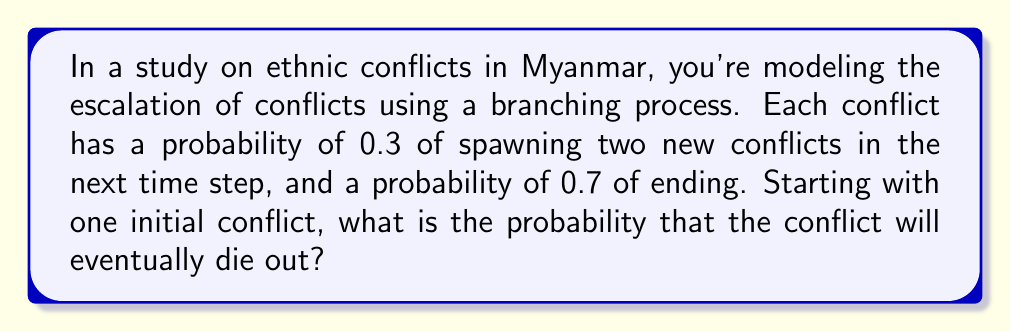Show me your answer to this math problem. To solve this problem, we'll use the theory of branching processes:

1) Let $p_0$ be the probability of a conflict ending (0.7), and $p_2$ be the probability of a conflict spawning two new conflicts (0.3).

2) The probability generating function (PGF) for this process is:
   $$f(s) = p_0 + p_2s^2 = 0.7 + 0.3s^2$$

3) The extinction probability $q$ is the smallest non-negative root of the equation $s = f(s)$. So we need to solve:
   $$s = 0.7 + 0.3s^2$$

4) Rearranging the equation:
   $$0.3s^2 - s + 0.7 = 0$$

5) This is a quadratic equation. We can solve it using the quadratic formula:
   $$s = \frac{1 \pm \sqrt{1 - 4(0.3)(0.7)}}{2(0.3)}$$

6) Simplifying:
   $$s = \frac{1 \pm \sqrt{0.16}}{0.6} = \frac{1 \pm 0.4}{0.6}$$

7) This gives us two solutions:
   $$s_1 = \frac{1 + 0.4}{0.6} = \frac{1.4}{0.6} \approx 2.33$$
   $$s_2 = \frac{1 - 0.4}{0.6} = \frac{0.6}{0.6} = 1$$

8) The extinction probability is the smallest non-negative root, which is 1.

Therefore, the probability that the conflict will eventually die out is 1, or 100%.
Answer: 1 